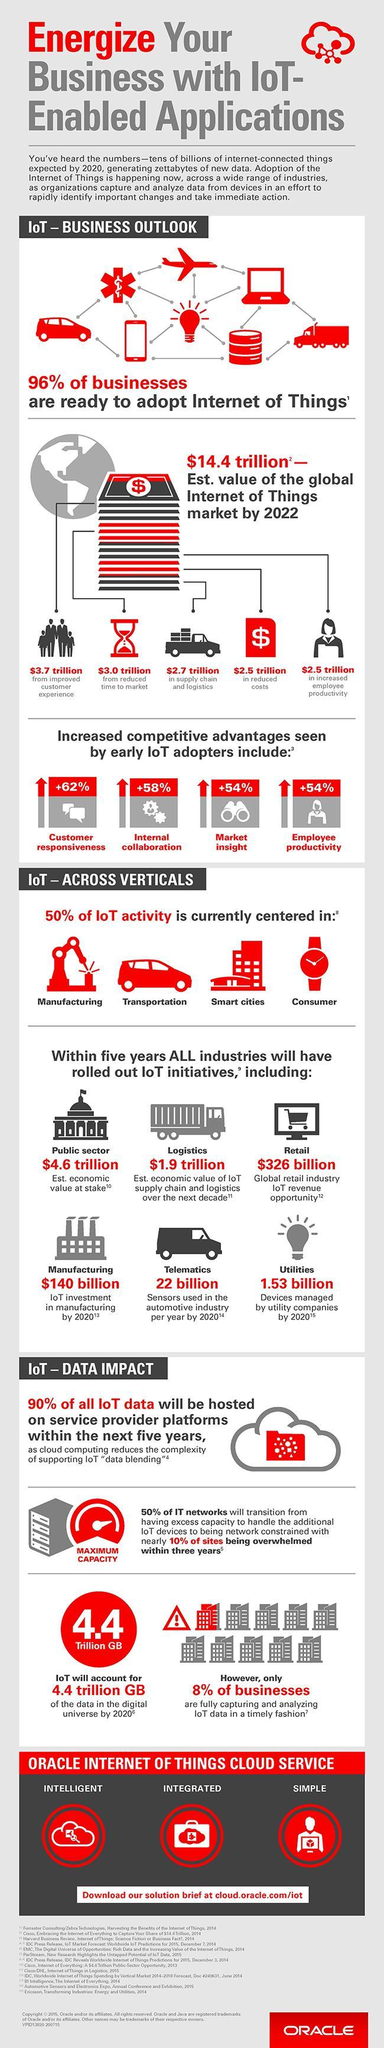What is the percentage increase in customer responsiveness due to IoT?
Answer the question with a short phrase. 62% What is the IoT revenue opportunity in global retail industry? $326 billion 